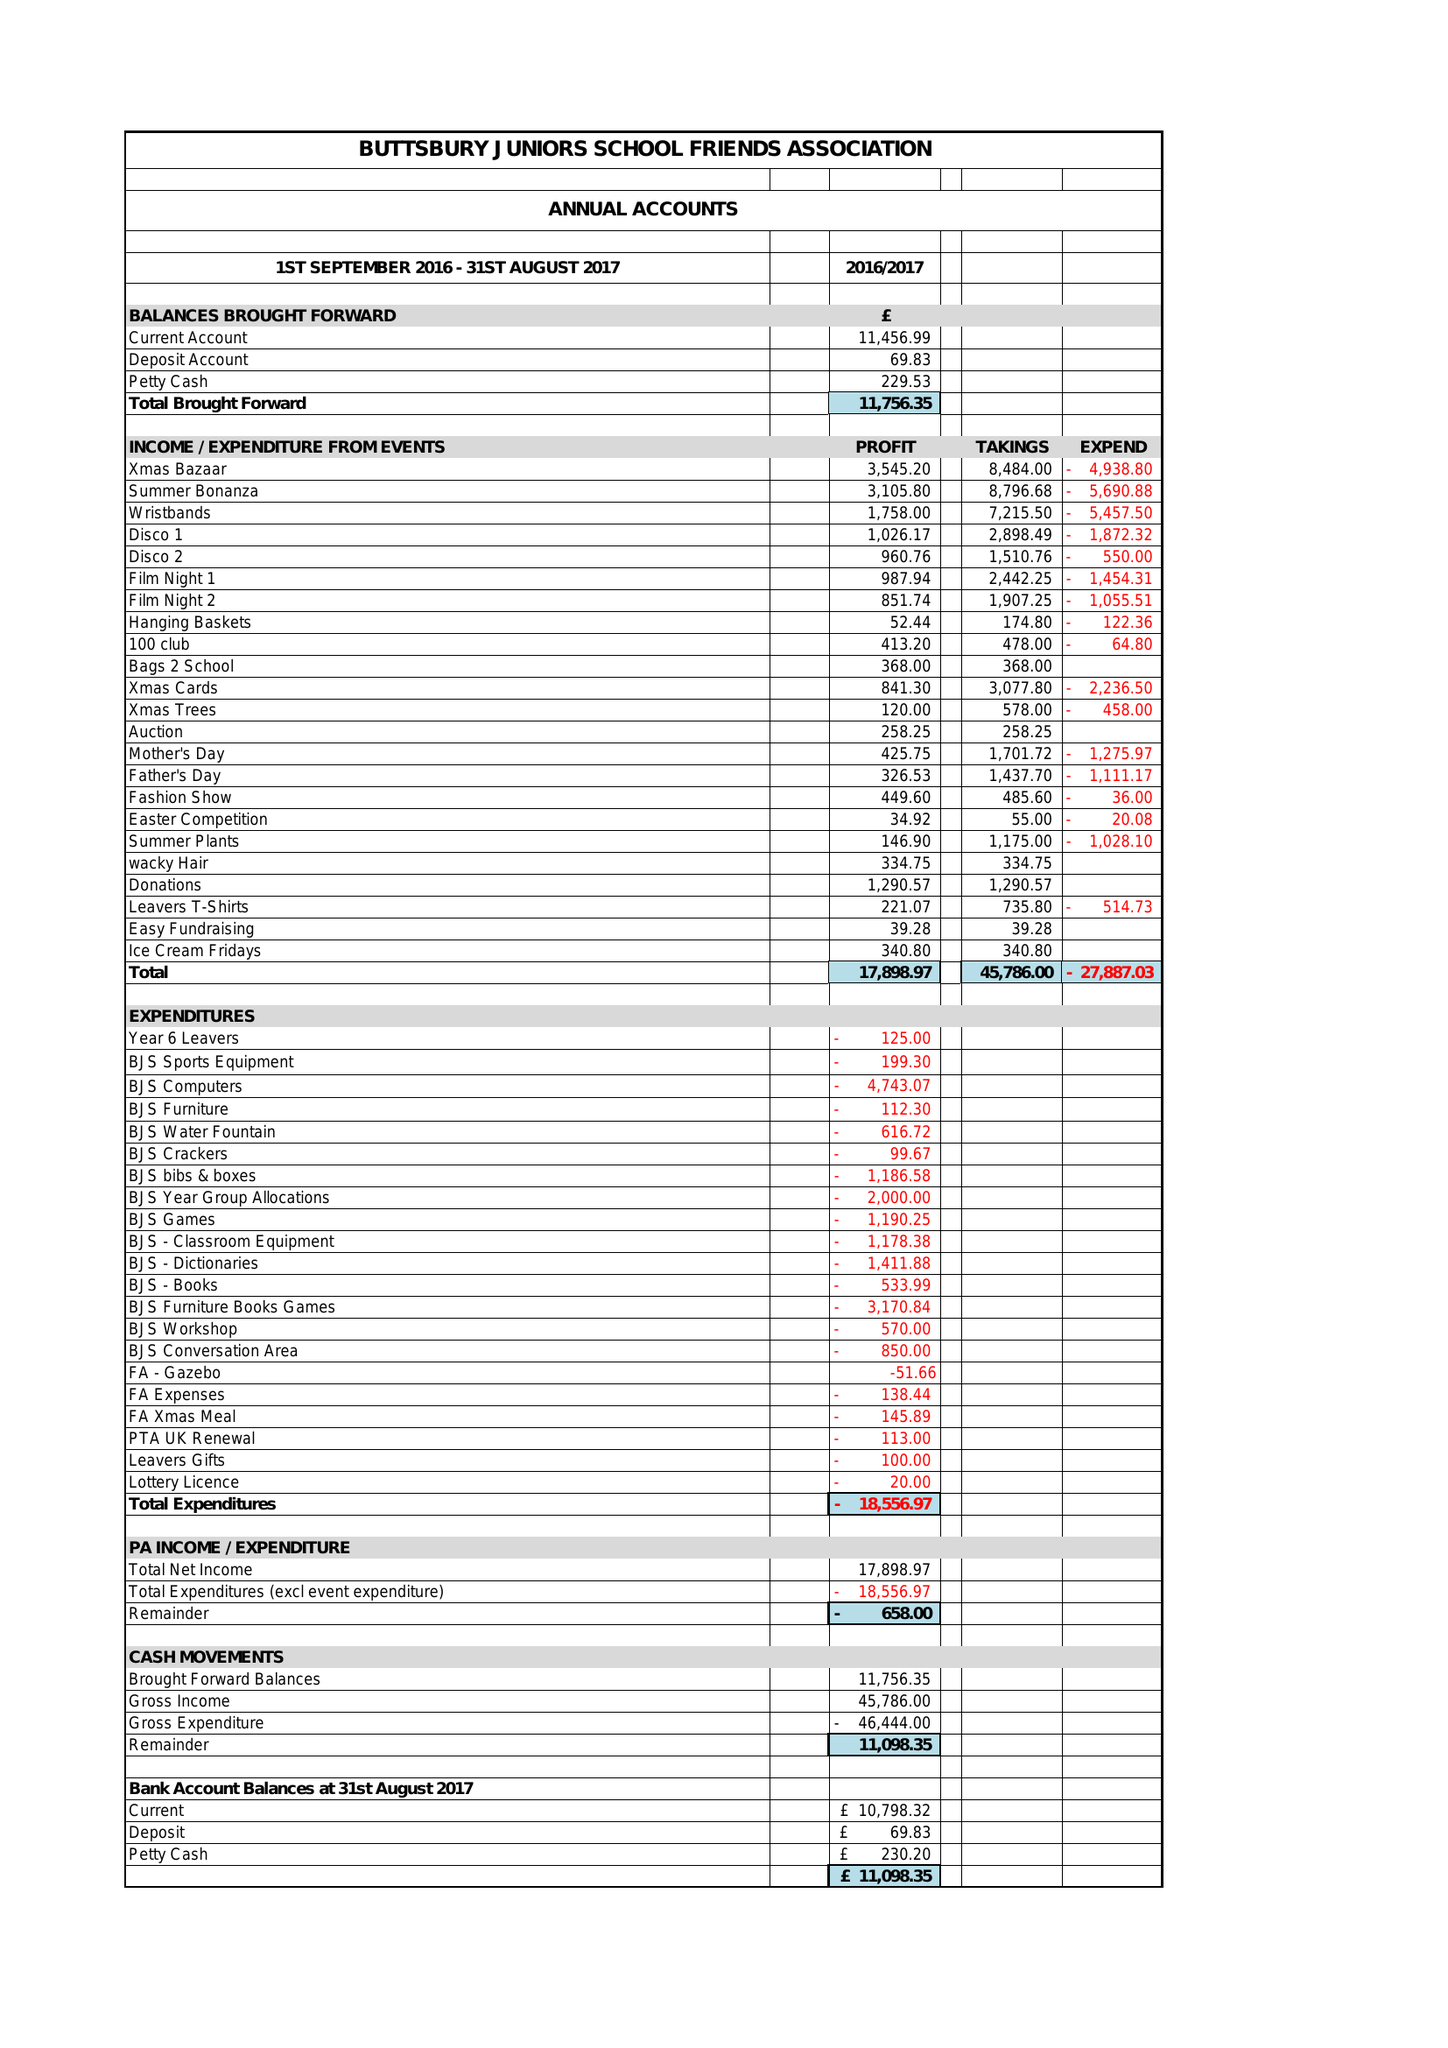What is the value for the charity_name?
Answer the question using a single word or phrase. Buttsbury Junior School Friends Association 